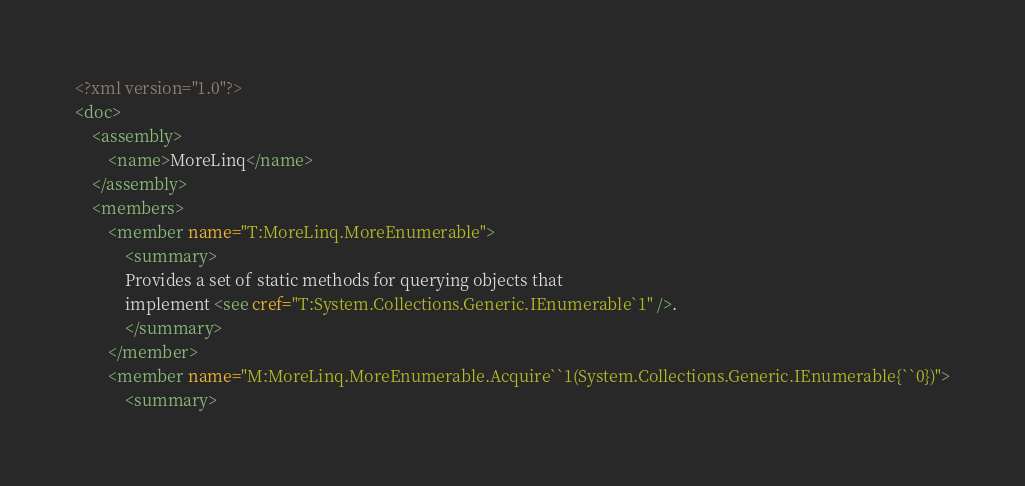Convert code to text. <code><loc_0><loc_0><loc_500><loc_500><_XML_><?xml version="1.0"?>
<doc>
    <assembly>
        <name>MoreLinq</name>
    </assembly>
    <members>
        <member name="T:MoreLinq.MoreEnumerable">
            <summary>
            Provides a set of static methods for querying objects that
            implement <see cref="T:System.Collections.Generic.IEnumerable`1" />.
            </summary>
        </member>
        <member name="M:MoreLinq.MoreEnumerable.Acquire``1(System.Collections.Generic.IEnumerable{``0})">
            <summary></code> 